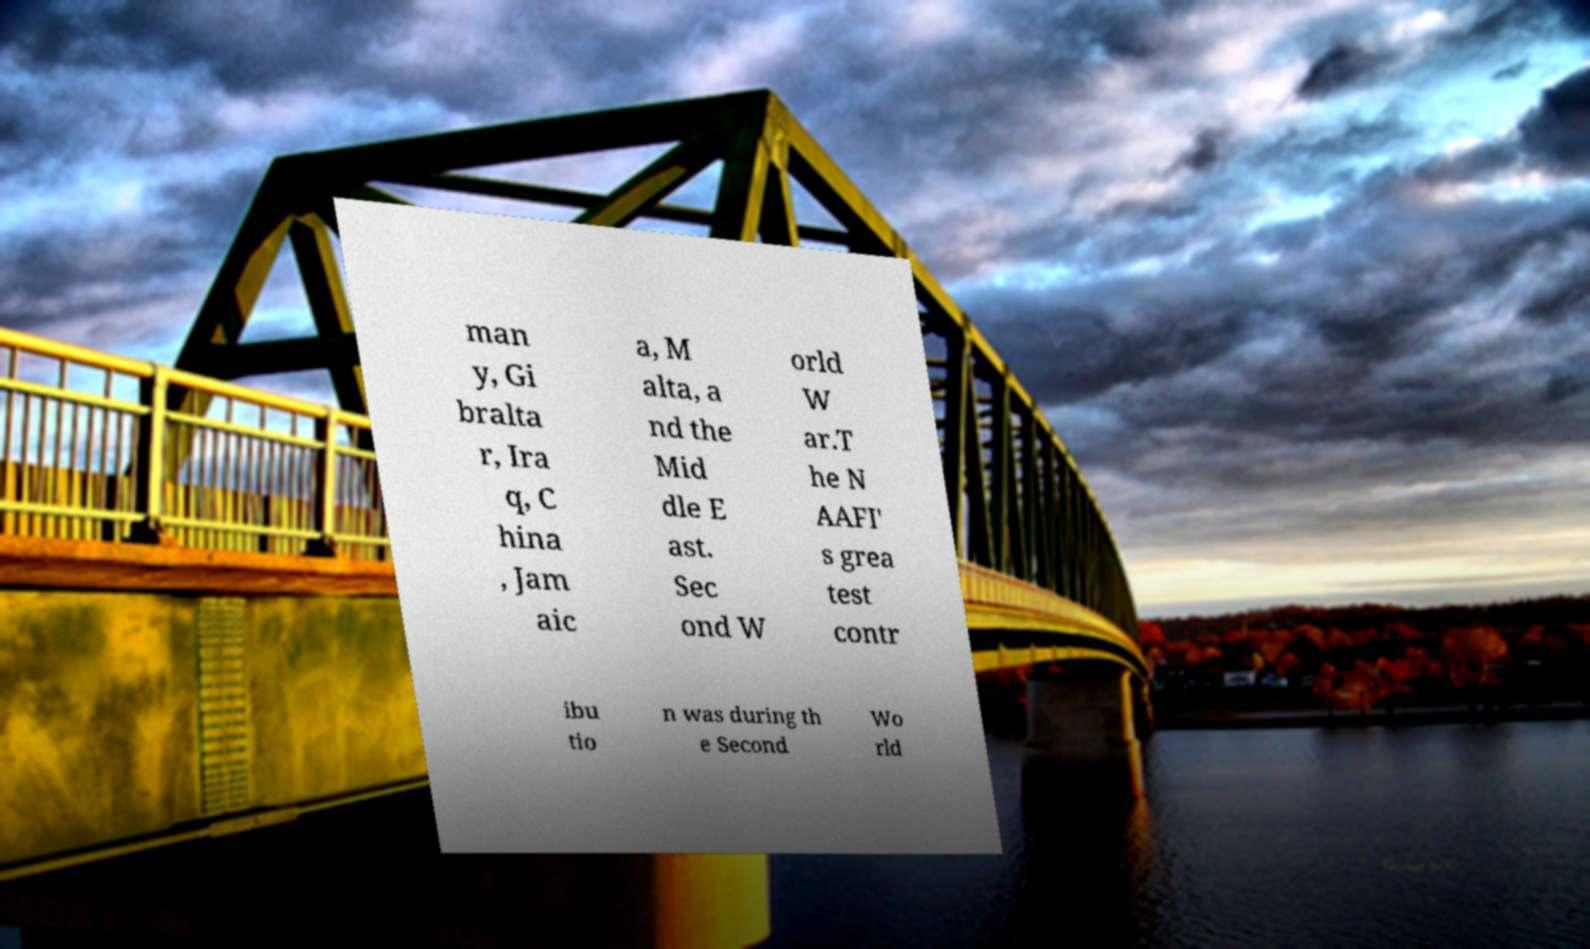Could you extract and type out the text from this image? man y, Gi bralta r, Ira q, C hina , Jam aic a, M alta, a nd the Mid dle E ast. Sec ond W orld W ar.T he N AAFI' s grea test contr ibu tio n was during th e Second Wo rld 